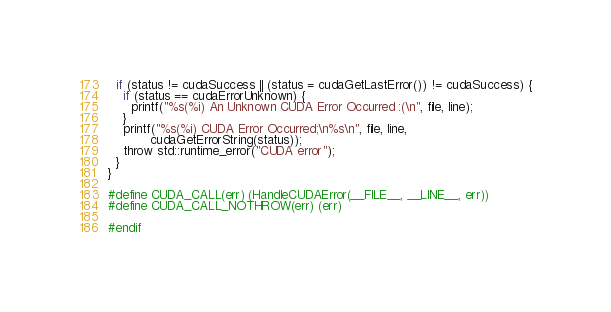<code> <loc_0><loc_0><loc_500><loc_500><_Cuda_>  if (status != cudaSuccess || (status = cudaGetLastError()) != cudaSuccess) {
    if (status == cudaErrorUnknown) {
      printf("%s(%i) An Unknown CUDA Error Occurred :(\n", file, line);
    }
    printf("%s(%i) CUDA Error Occurred;\n%s\n", file, line,
           cudaGetErrorString(status));
    throw std::runtime_error("CUDA error");
  }
}

#define CUDA_CALL(err) (HandleCUDAError(__FILE__, __LINE__, err))
#define CUDA_CALL_NOTHROW(err) (err)

#endif</code> 